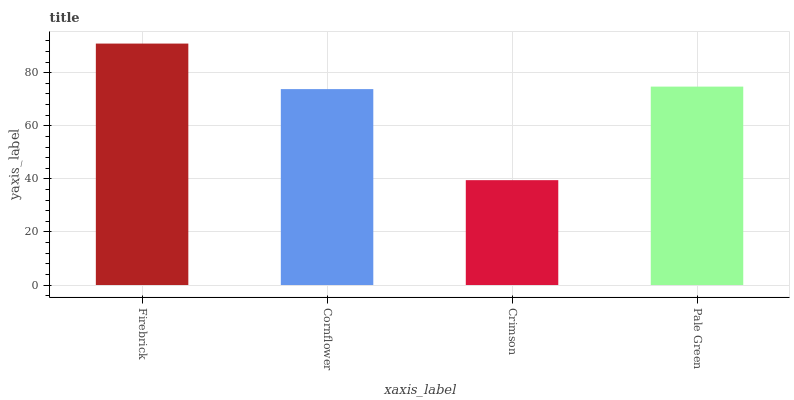Is Crimson the minimum?
Answer yes or no. Yes. Is Firebrick the maximum?
Answer yes or no. Yes. Is Cornflower the minimum?
Answer yes or no. No. Is Cornflower the maximum?
Answer yes or no. No. Is Firebrick greater than Cornflower?
Answer yes or no. Yes. Is Cornflower less than Firebrick?
Answer yes or no. Yes. Is Cornflower greater than Firebrick?
Answer yes or no. No. Is Firebrick less than Cornflower?
Answer yes or no. No. Is Pale Green the high median?
Answer yes or no. Yes. Is Cornflower the low median?
Answer yes or no. Yes. Is Cornflower the high median?
Answer yes or no. No. Is Crimson the low median?
Answer yes or no. No. 